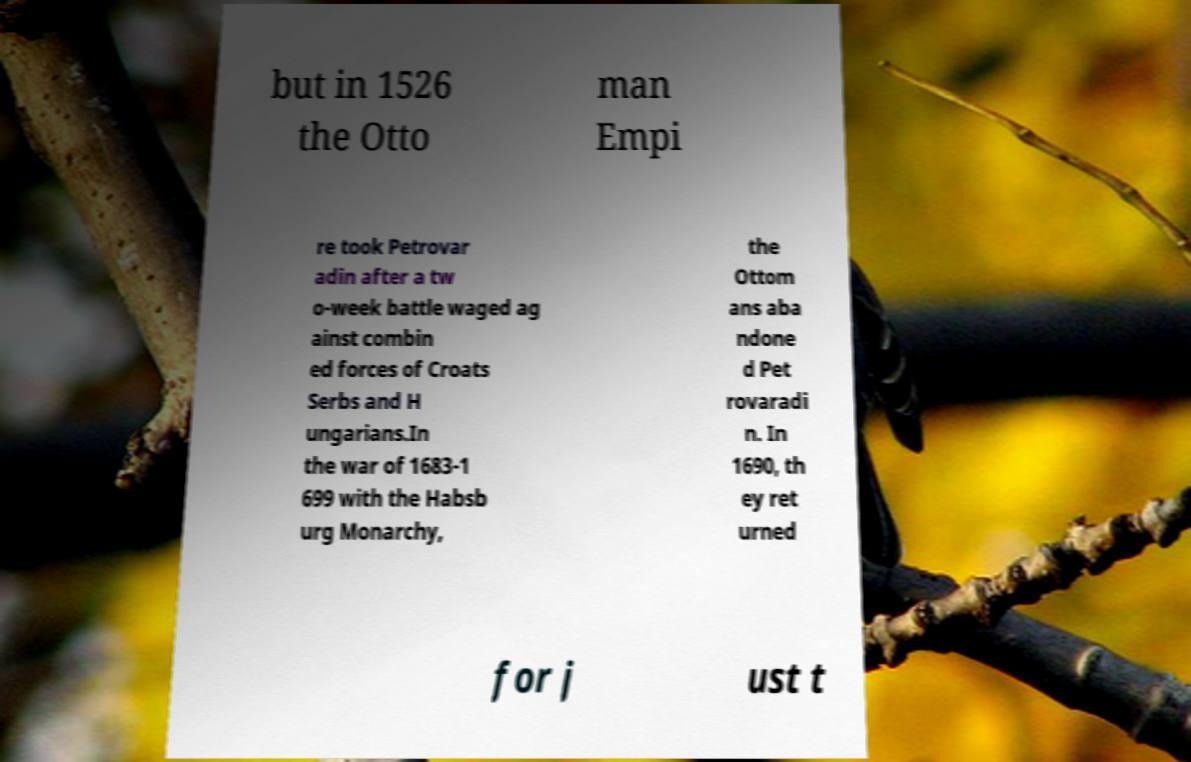Could you assist in decoding the text presented in this image and type it out clearly? but in 1526 the Otto man Empi re took Petrovar adin after a tw o-week battle waged ag ainst combin ed forces of Croats Serbs and H ungarians.In the war of 1683-1 699 with the Habsb urg Monarchy, the Ottom ans aba ndone d Pet rovaradi n. In 1690, th ey ret urned for j ust t 